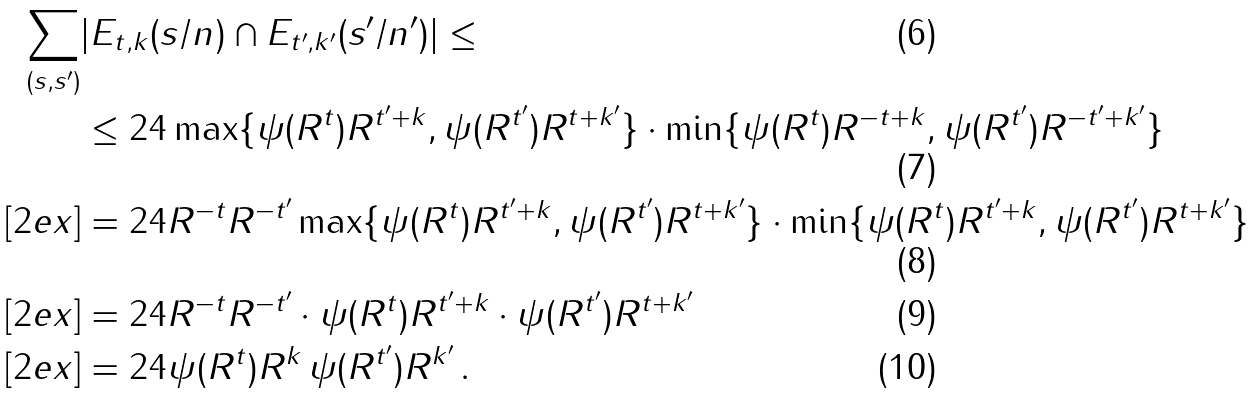<formula> <loc_0><loc_0><loc_500><loc_500>\sum _ { ( s , s ^ { \prime } ) } & | E _ { t , k } ( s / n ) \cap E _ { t ^ { \prime } , k ^ { \prime } } ( s ^ { \prime } / n ^ { \prime } ) | \leq \\ & \leq 2 4 \max \{ \psi ( R ^ { t } ) R ^ { t ^ { \prime } + k } , \psi ( R ^ { t ^ { \prime } } ) R ^ { t + k ^ { \prime } } \} \cdot \min \{ \psi ( R ^ { t } ) R ^ { - t + k } , \psi ( R ^ { t ^ { \prime } } ) R ^ { - t ^ { \prime } + k ^ { \prime } } \} \\ [ 2 e x ] & = 2 4 R ^ { - t } R ^ { - t ^ { \prime } } \max \{ \psi ( R ^ { t } ) R ^ { t ^ { \prime } + k } , \psi ( R ^ { t ^ { \prime } } ) R ^ { t + k ^ { \prime } } \} \cdot \min \{ \psi ( R ^ { t } ) R ^ { t ^ { \prime } + k } , \psi ( R ^ { t ^ { \prime } } ) R ^ { t + k ^ { \prime } } \} \\ [ 2 e x ] & = 2 4 R ^ { - t } R ^ { - t ^ { \prime } } \cdot \psi ( R ^ { t } ) R ^ { t ^ { \prime } + k } \cdot \psi ( R ^ { t ^ { \prime } } ) R ^ { t + k ^ { \prime } } \\ [ 2 e x ] & = 2 4 \psi ( R ^ { t } ) R ^ { k } \, \psi ( R ^ { t ^ { \prime } } ) R ^ { k ^ { \prime } } \, .</formula> 